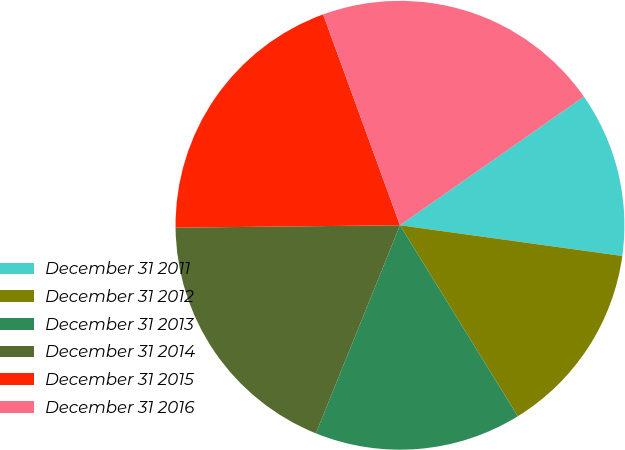Convert chart. <chart><loc_0><loc_0><loc_500><loc_500><pie_chart><fcel>December 31 2011<fcel>December 31 2012<fcel>December 31 2013<fcel>December 31 2014<fcel>December 31 2015<fcel>December 31 2016<nl><fcel>11.9%<fcel>14.02%<fcel>14.91%<fcel>18.72%<fcel>19.61%<fcel>20.85%<nl></chart> 